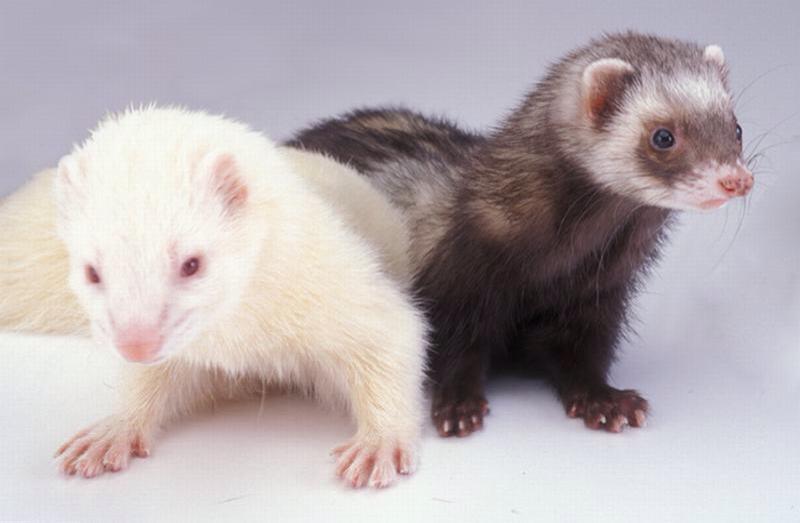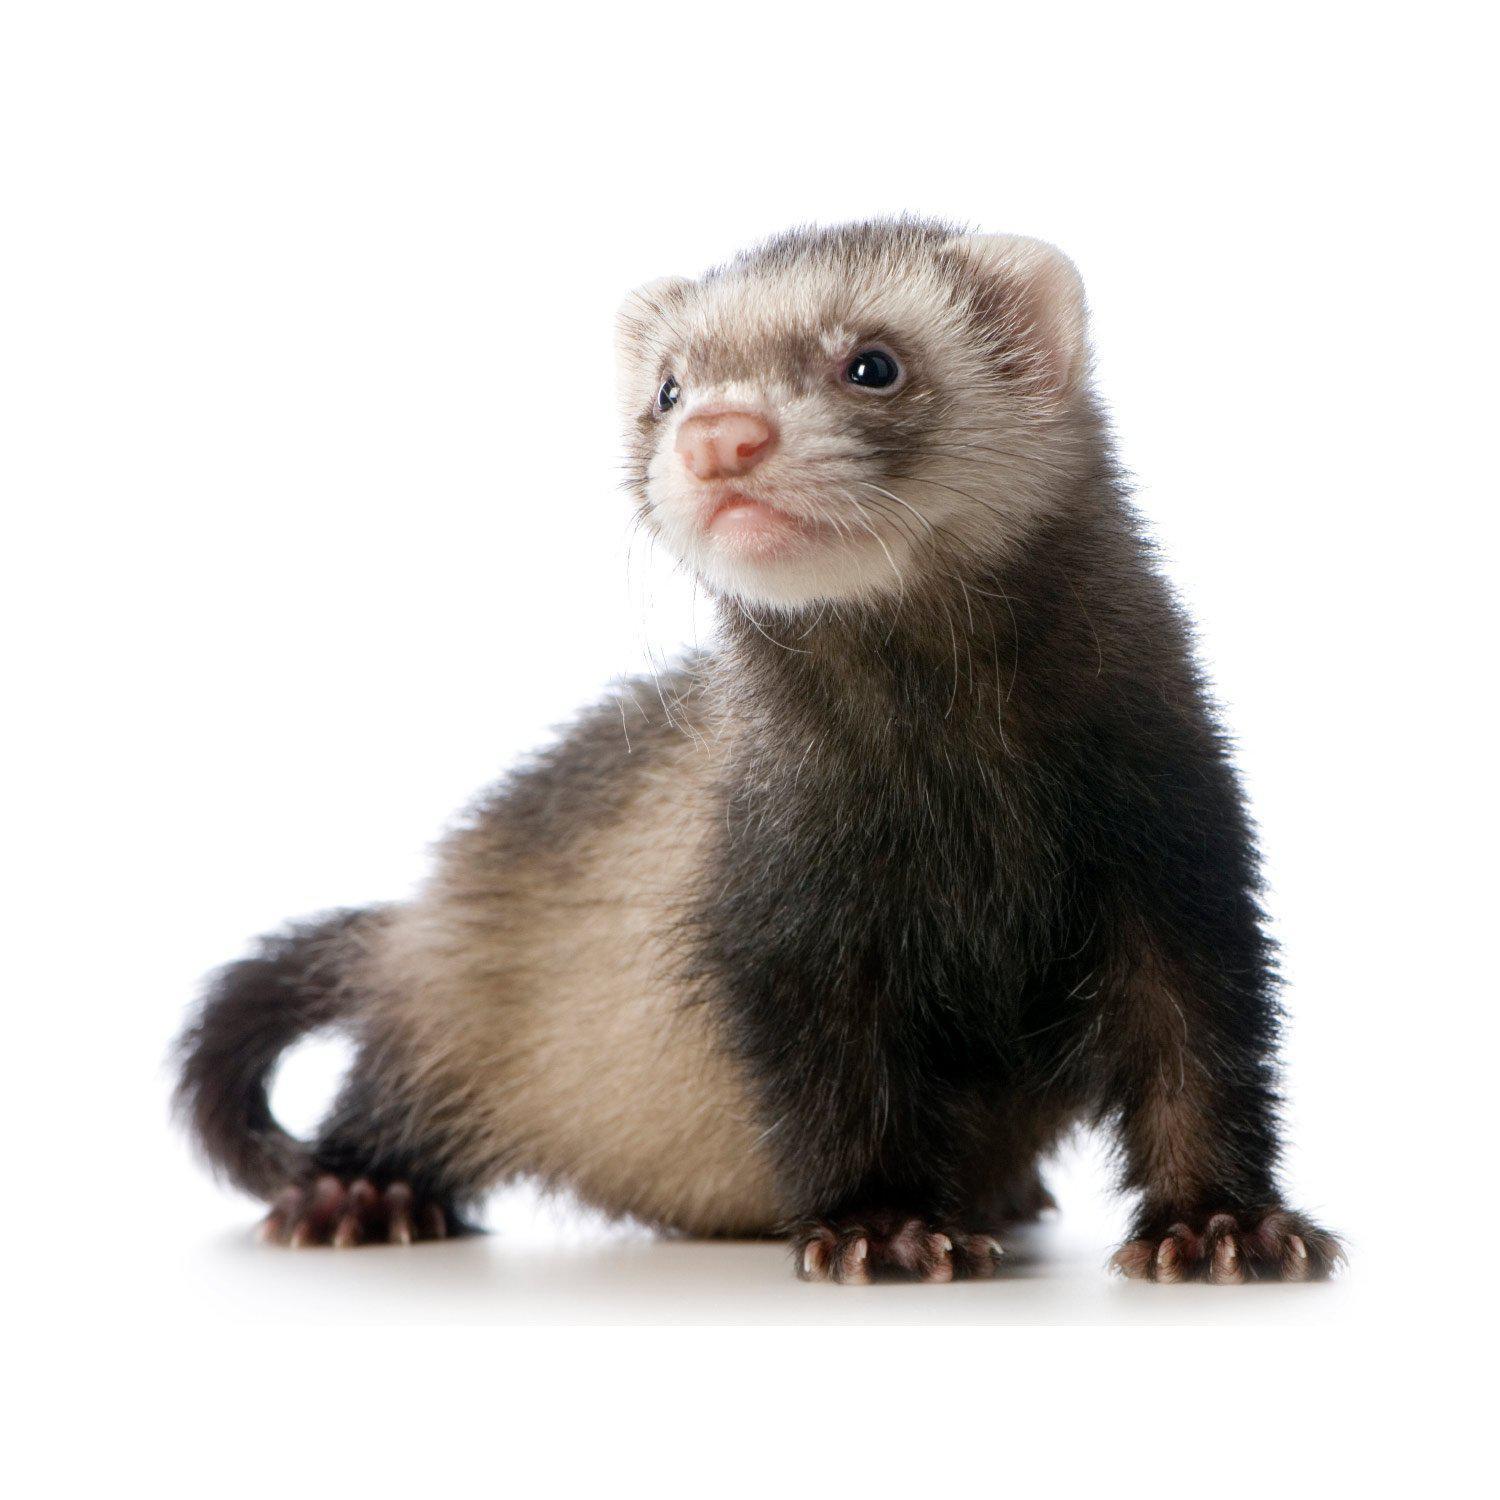The first image is the image on the left, the second image is the image on the right. Examine the images to the left and right. Is the description "The left image contains more ferrets than the right image." accurate? Answer yes or no. Yes. 